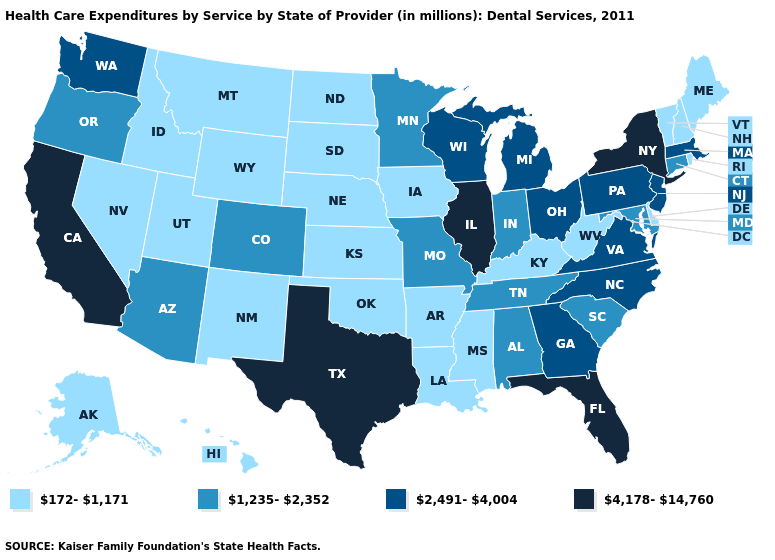Does Arizona have a lower value than Massachusetts?
Be succinct. Yes. Name the states that have a value in the range 4,178-14,760?
Quick response, please. California, Florida, Illinois, New York, Texas. Name the states that have a value in the range 1,235-2,352?
Answer briefly. Alabama, Arizona, Colorado, Connecticut, Indiana, Maryland, Minnesota, Missouri, Oregon, South Carolina, Tennessee. Which states have the highest value in the USA?
Concise answer only. California, Florida, Illinois, New York, Texas. What is the lowest value in the Northeast?
Write a very short answer. 172-1,171. Name the states that have a value in the range 2,491-4,004?
Quick response, please. Georgia, Massachusetts, Michigan, New Jersey, North Carolina, Ohio, Pennsylvania, Virginia, Washington, Wisconsin. Which states have the highest value in the USA?
Answer briefly. California, Florida, Illinois, New York, Texas. What is the value of Tennessee?
Answer briefly. 1,235-2,352. Among the states that border Pennsylvania , which have the highest value?
Quick response, please. New York. How many symbols are there in the legend?
Quick response, please. 4. What is the value of California?
Write a very short answer. 4,178-14,760. Name the states that have a value in the range 172-1,171?
Be succinct. Alaska, Arkansas, Delaware, Hawaii, Idaho, Iowa, Kansas, Kentucky, Louisiana, Maine, Mississippi, Montana, Nebraska, Nevada, New Hampshire, New Mexico, North Dakota, Oklahoma, Rhode Island, South Dakota, Utah, Vermont, West Virginia, Wyoming. Does Alabama have the highest value in the USA?
Answer briefly. No. What is the value of Washington?
Answer briefly. 2,491-4,004. What is the value of New Mexico?
Keep it brief. 172-1,171. 